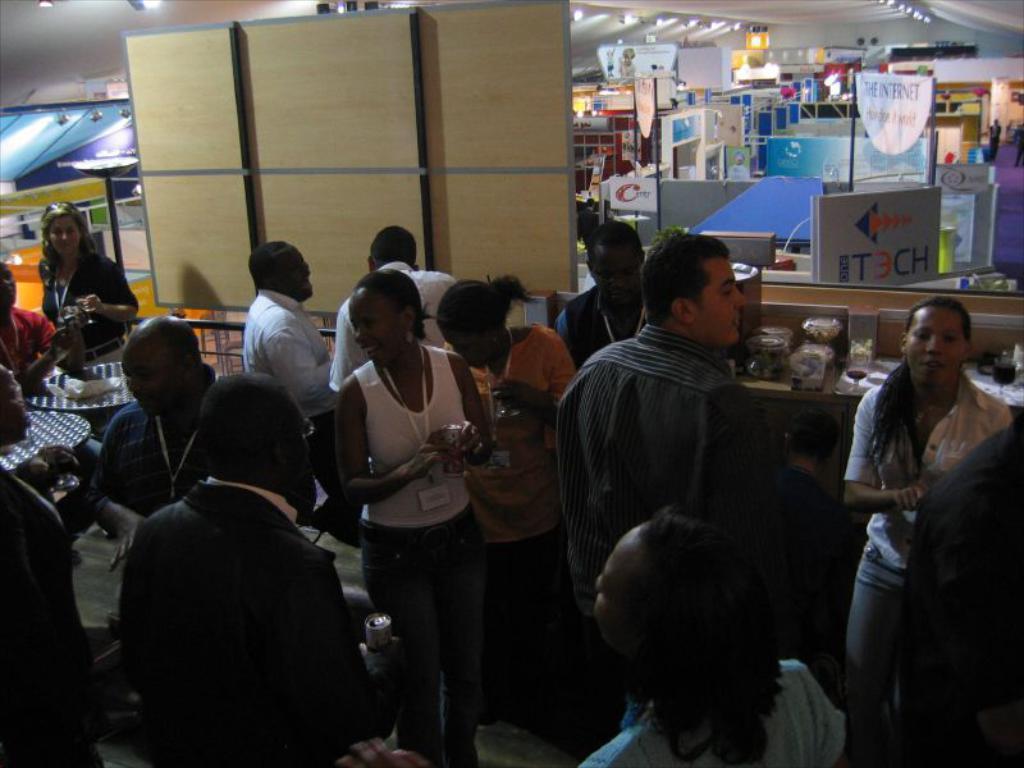Can you describe this image briefly? In the foreground of the of the image we can see some persons are standing. On the top of the image we can see a cardboard and some objects. 